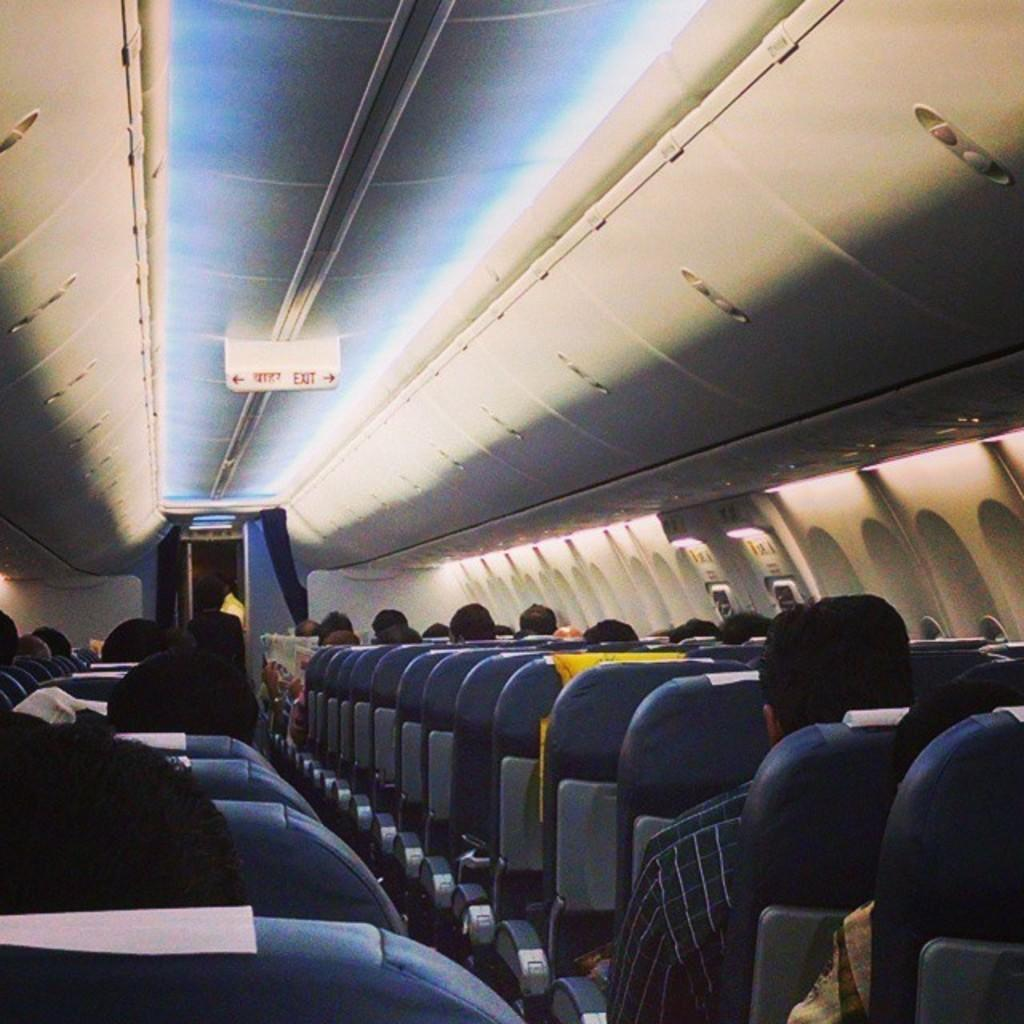<image>
Present a compact description of the photo's key features. The sign on the airplane ceiling shows the exits routes. 